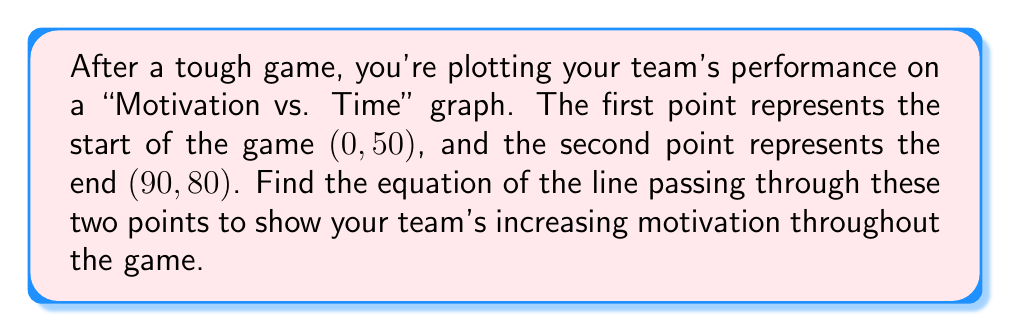Teach me how to tackle this problem. Let's approach this step-by-step:

1) We have two points: $(x_1, y_1) = (0, 50)$ and $(x_2, y_2) = (90, 80)$

2) To find the equation of a line passing through two points, we can use the point-slope form:

   $y - y_1 = m(x - x_1)$

   where $m$ is the slope of the line.

3) First, let's calculate the slope $m$:

   $m = \frac{y_2 - y_1}{x_2 - x_1} = \frac{80 - 50}{90 - 0} = \frac{30}{90} = \frac{1}{3}$

4) Now we can use either point and the slope in the point-slope form. Let's use $(0, 50)$:

   $y - 50 = \frac{1}{3}(x - 0)$

5) Simplify:

   $y - 50 = \frac{1}{3}x$

6) Add 50 to both sides to get the equation in slope-intercept form:

   $y = \frac{1}{3}x + 50$

This equation represents the line of increasing motivation throughout the game.
Answer: $y = \frac{1}{3}x + 50$ 